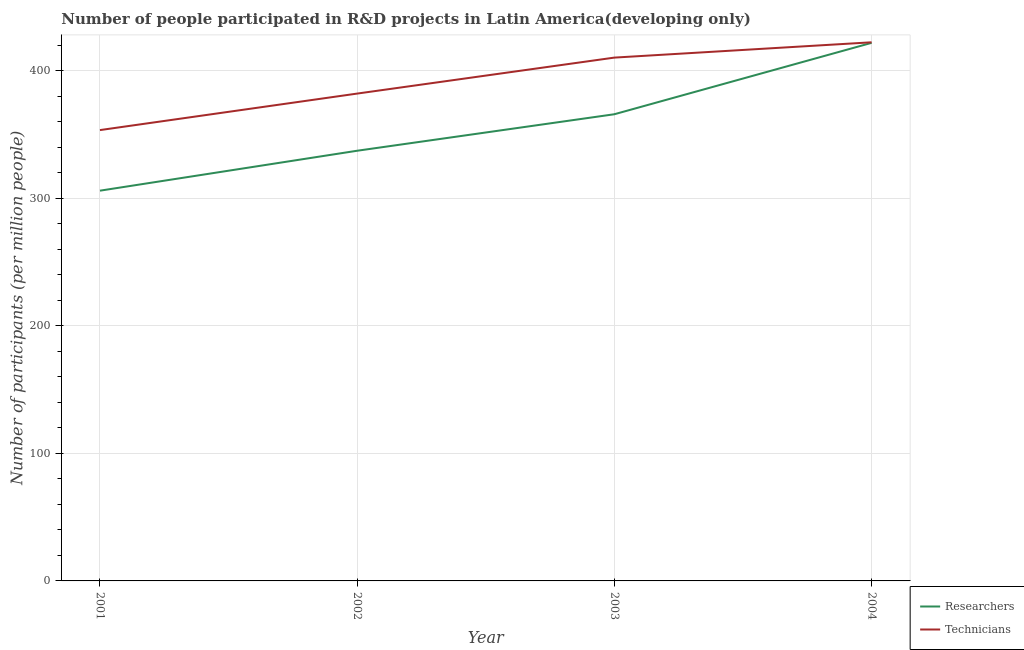What is the number of researchers in 2002?
Provide a short and direct response. 337.39. Across all years, what is the maximum number of technicians?
Keep it short and to the point. 422.45. Across all years, what is the minimum number of technicians?
Your answer should be compact. 353.59. In which year was the number of researchers minimum?
Offer a very short reply. 2001. What is the total number of technicians in the graph?
Offer a terse response. 1568.7. What is the difference between the number of technicians in 2001 and that in 2002?
Your answer should be very brief. -28.64. What is the difference between the number of technicians in 2004 and the number of researchers in 2002?
Make the answer very short. 85.06. What is the average number of technicians per year?
Provide a short and direct response. 392.17. In the year 2002, what is the difference between the number of technicians and number of researchers?
Offer a terse response. 44.83. In how many years, is the number of technicians greater than 400?
Offer a very short reply. 2. What is the ratio of the number of technicians in 2002 to that in 2004?
Make the answer very short. 0.9. Is the difference between the number of researchers in 2001 and 2002 greater than the difference between the number of technicians in 2001 and 2002?
Offer a terse response. No. What is the difference between the highest and the second highest number of technicians?
Your answer should be compact. 12.01. What is the difference between the highest and the lowest number of researchers?
Offer a very short reply. 115.93. In how many years, is the number of technicians greater than the average number of technicians taken over all years?
Ensure brevity in your answer.  2. Is the number of researchers strictly greater than the number of technicians over the years?
Your answer should be compact. No. Is the number of researchers strictly less than the number of technicians over the years?
Give a very brief answer. Yes. How many lines are there?
Offer a terse response. 2. Does the graph contain grids?
Make the answer very short. Yes. Where does the legend appear in the graph?
Offer a very short reply. Bottom right. How many legend labels are there?
Keep it short and to the point. 2. How are the legend labels stacked?
Offer a terse response. Vertical. What is the title of the graph?
Provide a succinct answer. Number of people participated in R&D projects in Latin America(developing only). Does "Arms imports" appear as one of the legend labels in the graph?
Make the answer very short. No. What is the label or title of the Y-axis?
Your answer should be very brief. Number of participants (per million people). What is the Number of participants (per million people) of Researchers in 2001?
Make the answer very short. 306.07. What is the Number of participants (per million people) of Technicians in 2001?
Keep it short and to the point. 353.59. What is the Number of participants (per million people) in Researchers in 2002?
Offer a very short reply. 337.39. What is the Number of participants (per million people) in Technicians in 2002?
Provide a short and direct response. 382.22. What is the Number of participants (per million people) in Researchers in 2003?
Provide a succinct answer. 366.02. What is the Number of participants (per million people) in Technicians in 2003?
Provide a succinct answer. 410.44. What is the Number of participants (per million people) of Researchers in 2004?
Provide a short and direct response. 422.01. What is the Number of participants (per million people) of Technicians in 2004?
Make the answer very short. 422.45. Across all years, what is the maximum Number of participants (per million people) of Researchers?
Give a very brief answer. 422.01. Across all years, what is the maximum Number of participants (per million people) of Technicians?
Your response must be concise. 422.45. Across all years, what is the minimum Number of participants (per million people) of Researchers?
Make the answer very short. 306.07. Across all years, what is the minimum Number of participants (per million people) of Technicians?
Your response must be concise. 353.59. What is the total Number of participants (per million people) in Researchers in the graph?
Your answer should be very brief. 1431.49. What is the total Number of participants (per million people) of Technicians in the graph?
Make the answer very short. 1568.7. What is the difference between the Number of participants (per million people) in Researchers in 2001 and that in 2002?
Offer a very short reply. -31.32. What is the difference between the Number of participants (per million people) of Technicians in 2001 and that in 2002?
Offer a terse response. -28.64. What is the difference between the Number of participants (per million people) in Researchers in 2001 and that in 2003?
Your answer should be very brief. -59.95. What is the difference between the Number of participants (per million people) in Technicians in 2001 and that in 2003?
Your response must be concise. -56.85. What is the difference between the Number of participants (per million people) of Researchers in 2001 and that in 2004?
Provide a succinct answer. -115.93. What is the difference between the Number of participants (per million people) in Technicians in 2001 and that in 2004?
Your response must be concise. -68.86. What is the difference between the Number of participants (per million people) in Researchers in 2002 and that in 2003?
Ensure brevity in your answer.  -28.63. What is the difference between the Number of participants (per million people) in Technicians in 2002 and that in 2003?
Your response must be concise. -28.22. What is the difference between the Number of participants (per million people) in Researchers in 2002 and that in 2004?
Provide a short and direct response. -84.62. What is the difference between the Number of participants (per million people) of Technicians in 2002 and that in 2004?
Make the answer very short. -40.22. What is the difference between the Number of participants (per million people) of Researchers in 2003 and that in 2004?
Offer a very short reply. -55.98. What is the difference between the Number of participants (per million people) of Technicians in 2003 and that in 2004?
Ensure brevity in your answer.  -12.01. What is the difference between the Number of participants (per million people) of Researchers in 2001 and the Number of participants (per million people) of Technicians in 2002?
Provide a short and direct response. -76.15. What is the difference between the Number of participants (per million people) in Researchers in 2001 and the Number of participants (per million people) in Technicians in 2003?
Your answer should be very brief. -104.37. What is the difference between the Number of participants (per million people) of Researchers in 2001 and the Number of participants (per million people) of Technicians in 2004?
Ensure brevity in your answer.  -116.37. What is the difference between the Number of participants (per million people) in Researchers in 2002 and the Number of participants (per million people) in Technicians in 2003?
Make the answer very short. -73.05. What is the difference between the Number of participants (per million people) of Researchers in 2002 and the Number of participants (per million people) of Technicians in 2004?
Give a very brief answer. -85.06. What is the difference between the Number of participants (per million people) in Researchers in 2003 and the Number of participants (per million people) in Technicians in 2004?
Your response must be concise. -56.42. What is the average Number of participants (per million people) of Researchers per year?
Keep it short and to the point. 357.87. What is the average Number of participants (per million people) in Technicians per year?
Provide a succinct answer. 392.17. In the year 2001, what is the difference between the Number of participants (per million people) of Researchers and Number of participants (per million people) of Technicians?
Your response must be concise. -47.51. In the year 2002, what is the difference between the Number of participants (per million people) of Researchers and Number of participants (per million people) of Technicians?
Keep it short and to the point. -44.83. In the year 2003, what is the difference between the Number of participants (per million people) in Researchers and Number of participants (per million people) in Technicians?
Ensure brevity in your answer.  -44.42. In the year 2004, what is the difference between the Number of participants (per million people) of Researchers and Number of participants (per million people) of Technicians?
Your response must be concise. -0.44. What is the ratio of the Number of participants (per million people) of Researchers in 2001 to that in 2002?
Your response must be concise. 0.91. What is the ratio of the Number of participants (per million people) in Technicians in 2001 to that in 2002?
Offer a very short reply. 0.93. What is the ratio of the Number of participants (per million people) in Researchers in 2001 to that in 2003?
Offer a very short reply. 0.84. What is the ratio of the Number of participants (per million people) in Technicians in 2001 to that in 2003?
Your response must be concise. 0.86. What is the ratio of the Number of participants (per million people) in Researchers in 2001 to that in 2004?
Give a very brief answer. 0.73. What is the ratio of the Number of participants (per million people) of Technicians in 2001 to that in 2004?
Your answer should be very brief. 0.84. What is the ratio of the Number of participants (per million people) of Researchers in 2002 to that in 2003?
Your response must be concise. 0.92. What is the ratio of the Number of participants (per million people) in Technicians in 2002 to that in 2003?
Provide a succinct answer. 0.93. What is the ratio of the Number of participants (per million people) of Researchers in 2002 to that in 2004?
Give a very brief answer. 0.8. What is the ratio of the Number of participants (per million people) in Technicians in 2002 to that in 2004?
Your answer should be compact. 0.9. What is the ratio of the Number of participants (per million people) in Researchers in 2003 to that in 2004?
Your answer should be compact. 0.87. What is the ratio of the Number of participants (per million people) in Technicians in 2003 to that in 2004?
Offer a very short reply. 0.97. What is the difference between the highest and the second highest Number of participants (per million people) in Researchers?
Ensure brevity in your answer.  55.98. What is the difference between the highest and the second highest Number of participants (per million people) of Technicians?
Your answer should be compact. 12.01. What is the difference between the highest and the lowest Number of participants (per million people) of Researchers?
Your answer should be very brief. 115.93. What is the difference between the highest and the lowest Number of participants (per million people) in Technicians?
Your answer should be very brief. 68.86. 